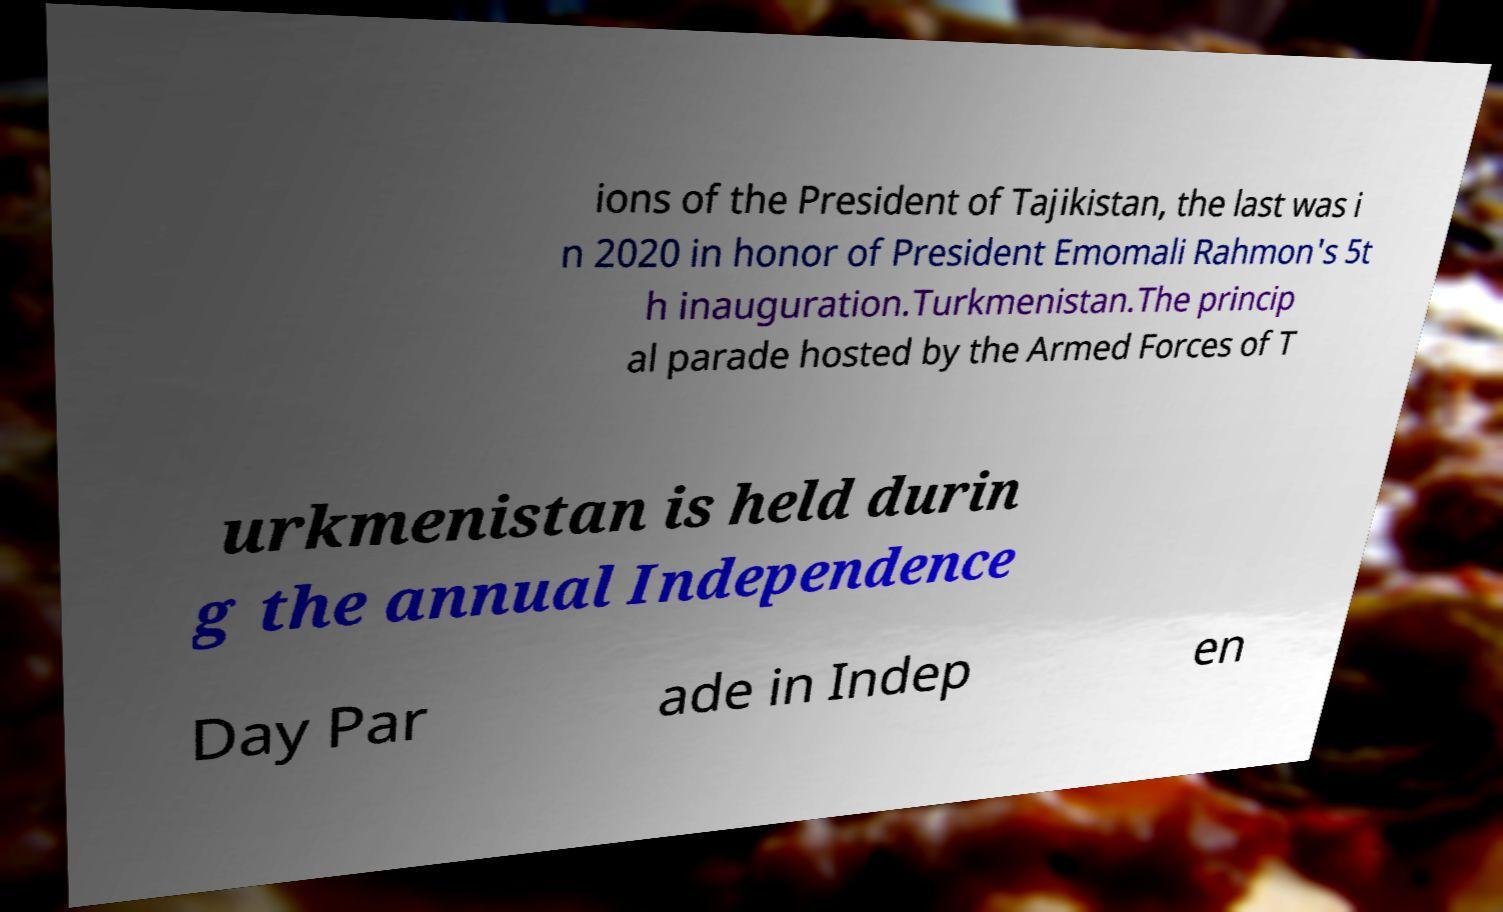Could you extract and type out the text from this image? ions of the President of Tajikistan, the last was i n 2020 in honor of President Emomali Rahmon's 5t h inauguration.Turkmenistan.The princip al parade hosted by the Armed Forces of T urkmenistan is held durin g the annual Independence Day Par ade in Indep en 